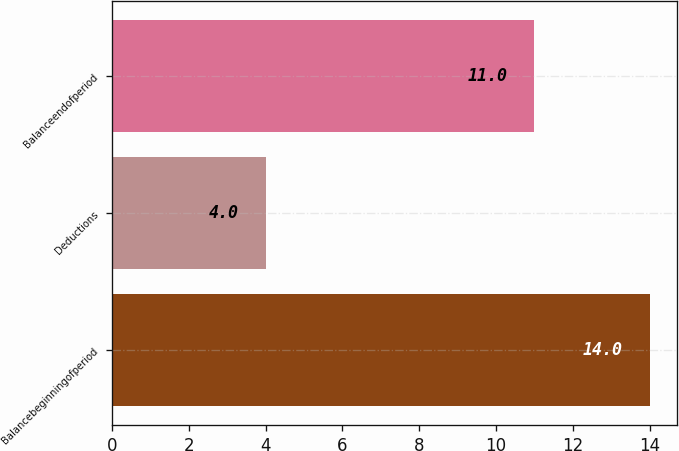Convert chart to OTSL. <chart><loc_0><loc_0><loc_500><loc_500><bar_chart><fcel>Balancebeginningofperiod<fcel>Deductions<fcel>Balanceendofperiod<nl><fcel>14<fcel>4<fcel>11<nl></chart> 